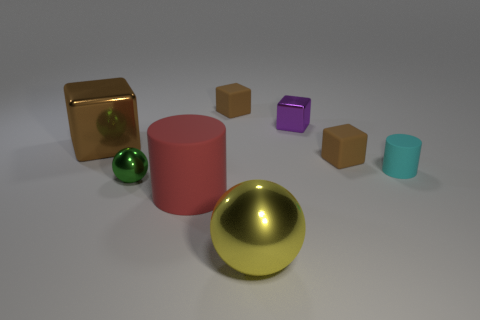What number of brown metal cubes are in front of the brown block in front of the large metal thing behind the cyan thing?
Give a very brief answer. 0. Is there a big red object made of the same material as the small cyan cylinder?
Your answer should be compact. Yes. Is the number of big red matte cylinders less than the number of big gray things?
Offer a terse response. No. There is a large object that is behind the small cyan matte cylinder; is it the same color as the big sphere?
Give a very brief answer. No. What is the cylinder that is on the right side of the brown matte cube on the right side of the brown matte block that is behind the tiny metal block made of?
Give a very brief answer. Rubber. Are there any large rubber cylinders of the same color as the small rubber cylinder?
Provide a succinct answer. No. Is the number of big shiny cubes that are behind the large brown metal thing less than the number of small purple things?
Your answer should be very brief. Yes. There is a brown rubber object that is right of the yellow metallic thing; is it the same size as the large cylinder?
Provide a short and direct response. No. What number of tiny things are in front of the brown metal object and on the right side of the large yellow metal object?
Provide a short and direct response. 2. What size is the matte cylinder that is behind the cylinder that is in front of the small cyan rubber cylinder?
Keep it short and to the point. Small. 